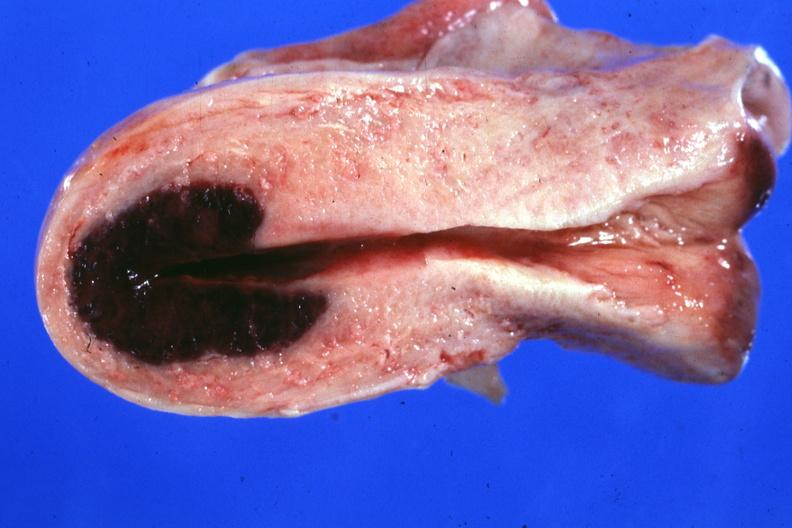does this typical lesion show localized lesion in dome of uterus said to have adenosis adenomyosis hemorrhage probably due to shock?
Answer the question using a single word or phrase. No 